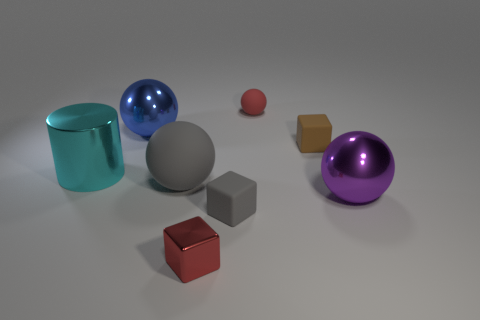The small thing that is the same color as the metal block is what shape?
Your response must be concise. Sphere. How big is the thing that is left of the metallic thing behind the big cyan object?
Provide a succinct answer. Large. What is the color of the other matte object that is the same shape as the large gray rubber object?
Offer a very short reply. Red. How many metallic cylinders are the same color as the tiny metallic cube?
Your response must be concise. 0. How big is the gray sphere?
Provide a short and direct response. Large. Is the cyan shiny thing the same size as the gray rubber block?
Offer a terse response. No. There is a big object that is both to the right of the blue shiny object and to the left of the tiny red rubber sphere; what color is it?
Keep it short and to the point. Gray. What number of big blue objects have the same material as the big purple sphere?
Your response must be concise. 1. How many cyan metallic cylinders are there?
Make the answer very short. 1. There is a brown rubber cube; is its size the same as the matte object that is behind the blue metal thing?
Give a very brief answer. Yes. 